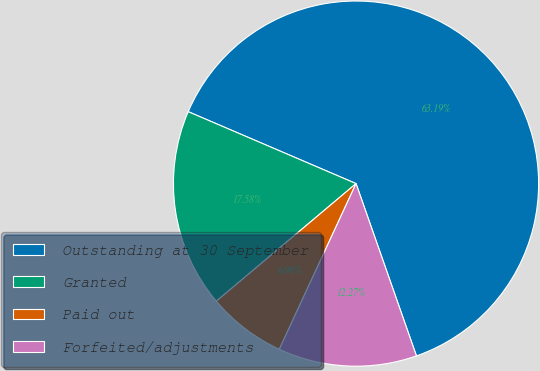Convert chart. <chart><loc_0><loc_0><loc_500><loc_500><pie_chart><fcel>Outstanding at 30 September<fcel>Granted<fcel>Paid out<fcel>Forfeited/adjustments<nl><fcel>63.19%<fcel>17.58%<fcel>6.96%<fcel>12.27%<nl></chart> 